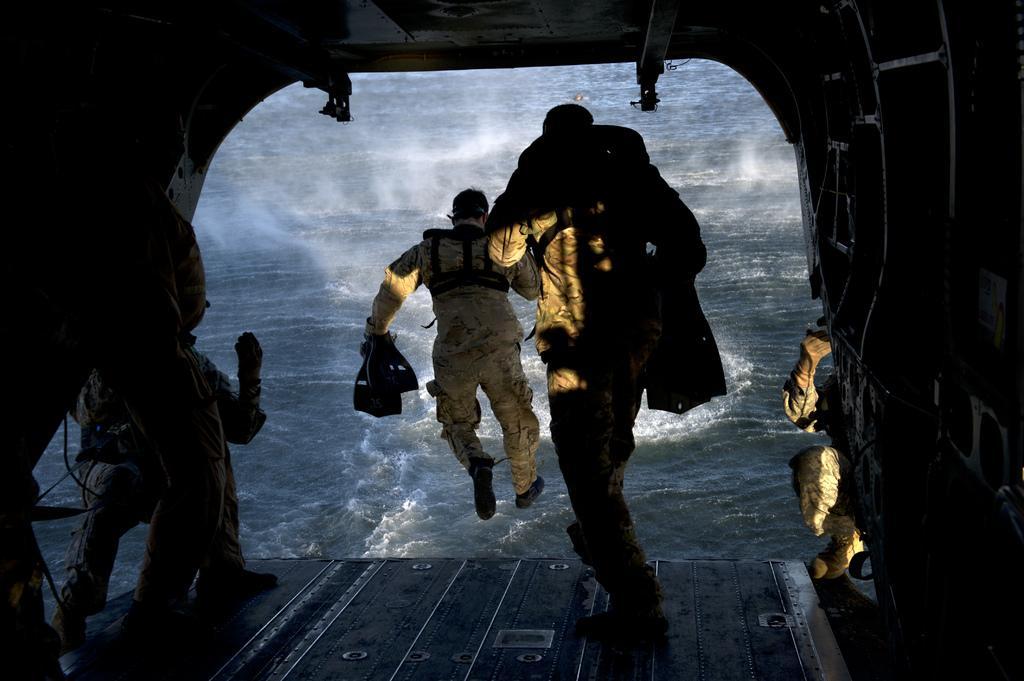In one or two sentences, can you explain what this image depicts? In this picture I can see people, water, roof and walls. These people are holding objects. 